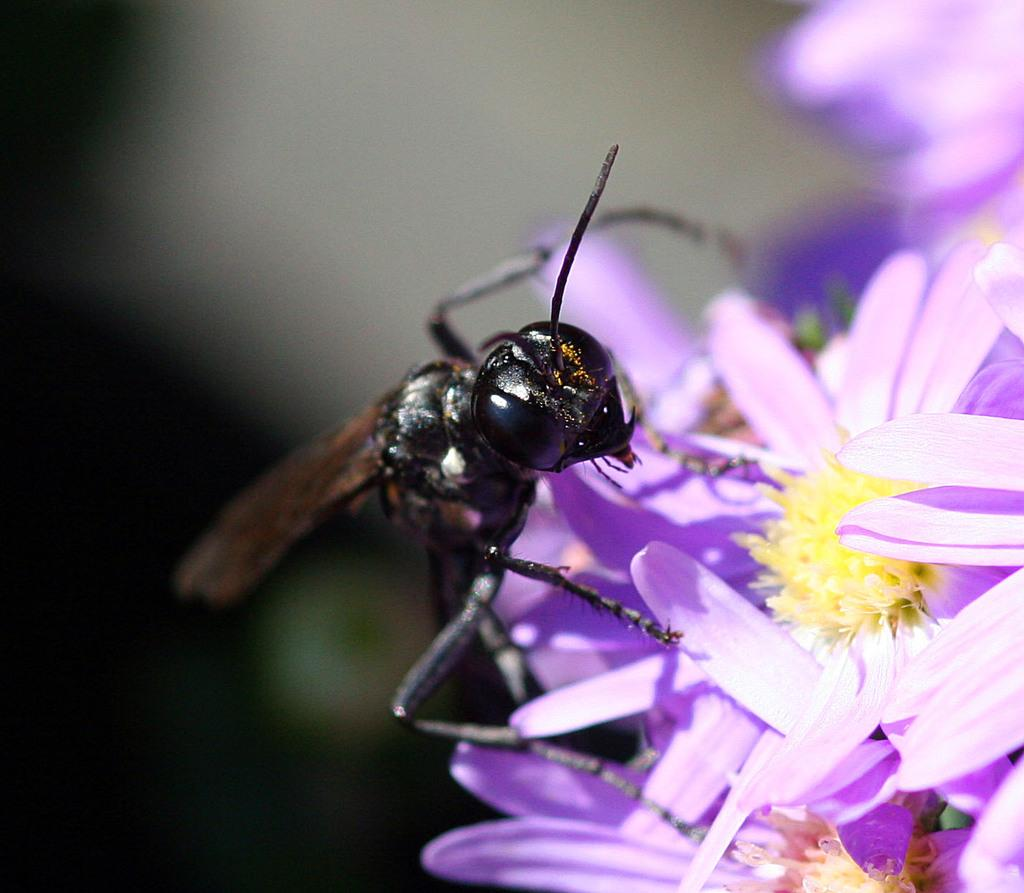What type of creature is present in the image? There is an insect in the image. Where is the insect located in the image? The insect is on a group of flowers. What type of cherries can be seen hanging from the yarn in the image? There is no mention of cherries or yarn in the image; it features an insect on a group of flowers. 